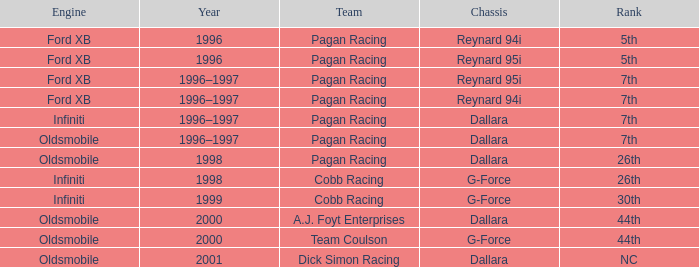In the reynard 95i chassis, which engine achieved a 7th place finish? Ford XB. 